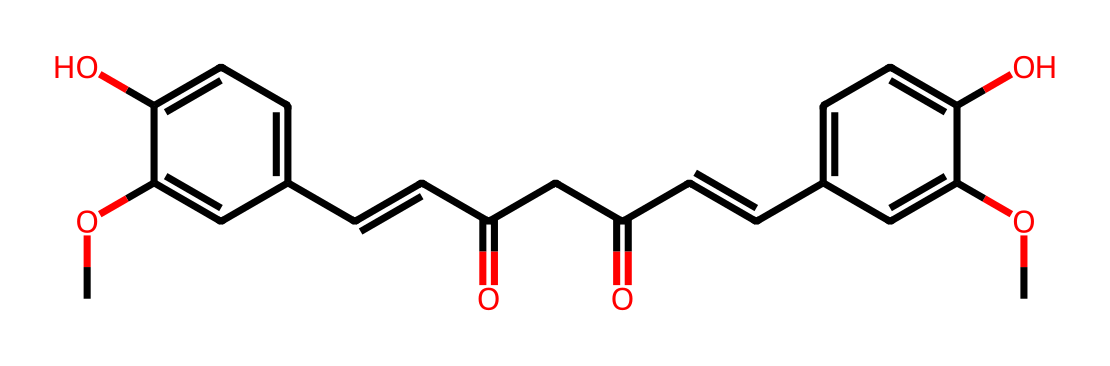How many carbon atoms are present in the structure of curcumin? By examining the SMILES representation, we can count the number of carbon (C) atoms depicted. The C atoms appear throughout the structure, leading to a total of 21 carbon atoms.
Answer: 21 What is the highest oxidation state of oxygen found in curcumin? In the structure, the oxygen atoms (O) are attached to hydroxyl groups (–OH) and carbonyl groups (C=O). The carbonyl oxygen (C=O) is in its highest oxidation state of +2.
Answer: +2 Does curcumin contain any conjugated double bonds? Yes, by analyzing the structure, we can identify the presence of double bonds. The connectivity shows multiple C=C bonds indicating conjugation which is often involved in light absorption for biological activity.
Answer: Yes How many hydroxyl groups are there in curcumin? By visually inspecting the structure, we can spot the –OH groups (hydroxyl groups). There are two –OH groups present in the structure of curcumin.
Answer: 2 What type of chemical compound is curcumin classified as? Curcumin is classified as a phenolic compound due to the presence of phenol groups observed in the structure, characterized by the aromatic rings and hydroxyl groups.
Answer: phenolic compound What indicates the presence of conjugation in the curcumin structure? In the SMILES representation, the alternating double bonds and single bonds create a system of overlapping p-orbitals, indicating that the structure has extended π-electron delocalization, typical of conjugation.
Answer: alternating double bonds 